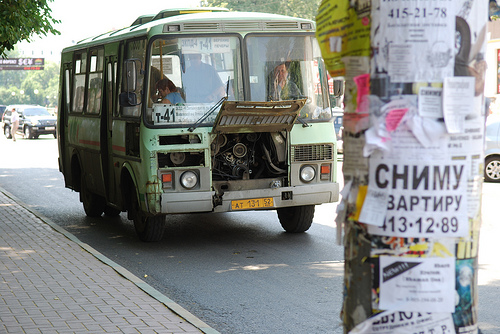<image>
Is the bus behind the post? Yes. From this viewpoint, the bus is positioned behind the post, with the post partially or fully occluding the bus. 